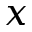<formula> <loc_0><loc_0><loc_500><loc_500>x</formula> 